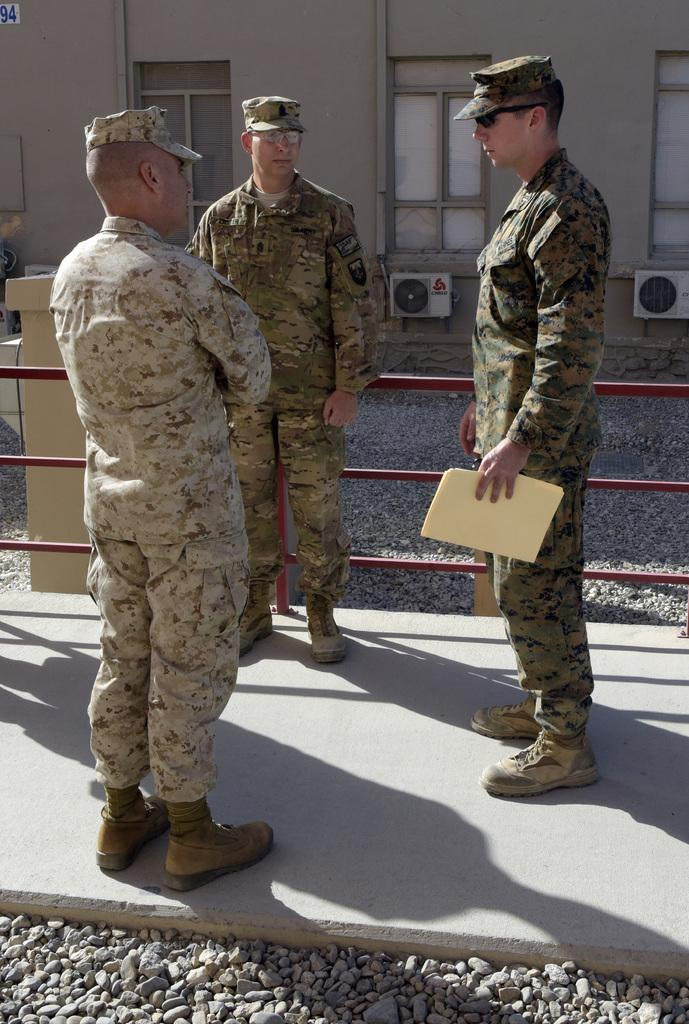How many officers are present in the image? There are three officers in the image. Where are the officers located? The officers are standing on the road and beside a fence. What can be seen in the background of the image? There is a building in the background of the image. Can you describe the building? The building has windows and AC ventilators. Where are the worms and dolls located in the image? There are no worms or dolls present in the image. What type of bait is being used by the officers in the image? There is no bait present in the image, as the officers are not engaged in any fishing activity. 